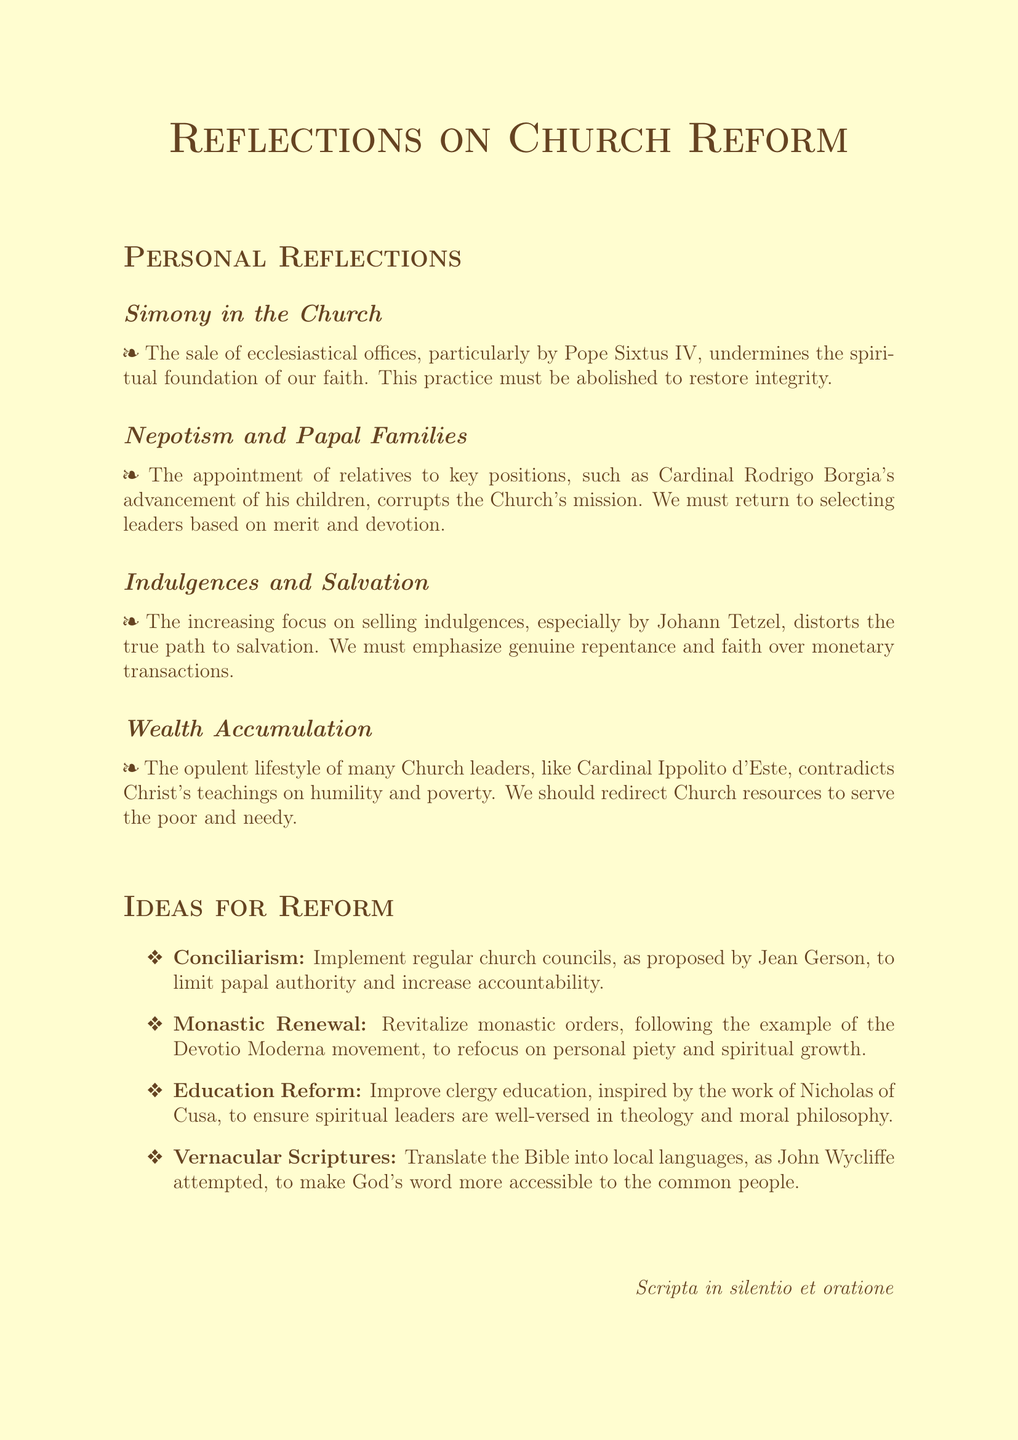What issue does the monk identify with Pope Sixtus IV? The monk points out the sale of ecclesiastical offices by Pope Sixtus IV, which undermines faith.
Answer: Sale of ecclesiastical offices What corrupt practice is associated with Cardinal Rodrigo Borgia? The monk highlights nepotism, specifically Cardinal Rodrigo Borgia's advancement of his children, as a corruption of the Church's mission.
Answer: Nepotism Who is blamed for the selling of indulgences? Johann Tetzel is specifically mentioned as increasing the focus on selling indulgences.
Answer: Johann Tetzel What lifestyle of Church leaders contradicts Christ's teachings? The opulent lifestyle of Church leaders, like Cardinal Ippolito d'Este, is seen as contradictory to Christ's teachings on humility.
Answer: Opulent lifestyle Which reform idea involves regular church councils? The reform idea of Conciliarism involves implementing regular church councils.
Answer: Conciliarism What movement is suggested for monastic renewal? The monk suggests following the Devotio Moderna movement for monastic renewal.
Answer: Devotio Moderna Who proposed the idea for improving clergy education? Nicholas of Cusa is referenced as the inspiration for improving clergy education.
Answer: Nicholas of Cusa What strategy is recommended for making the Bible more accessible? Translating the Bible into local languages is the recommended strategy for accessibility.
Answer: Local languages 